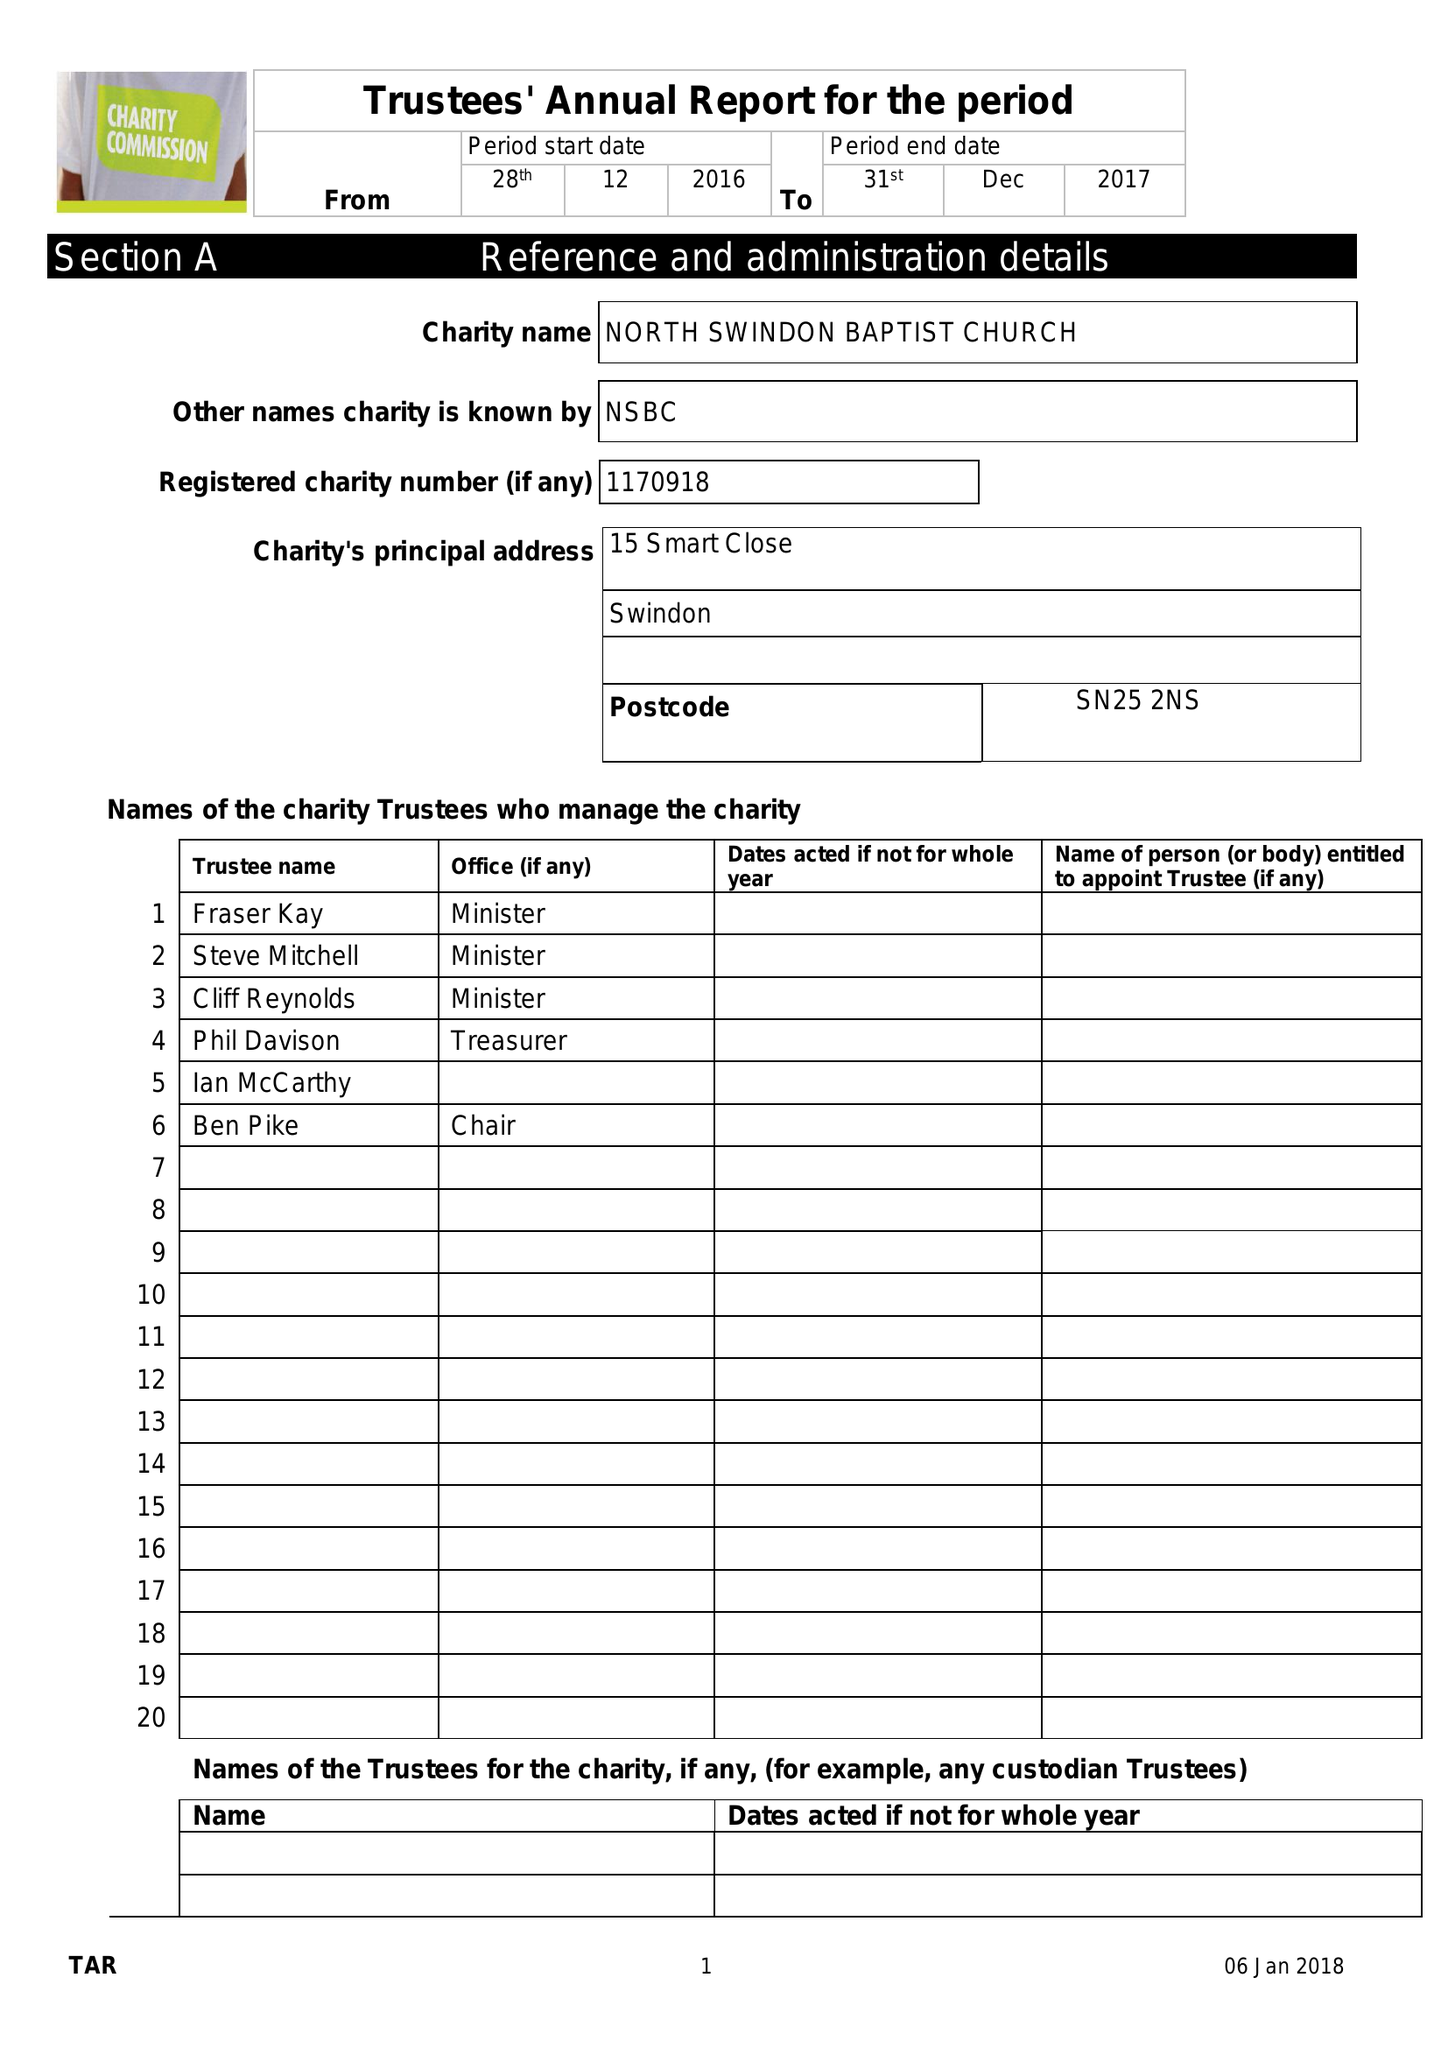What is the value for the charity_name?
Answer the question using a single word or phrase. North Swindon Baptist  Church 